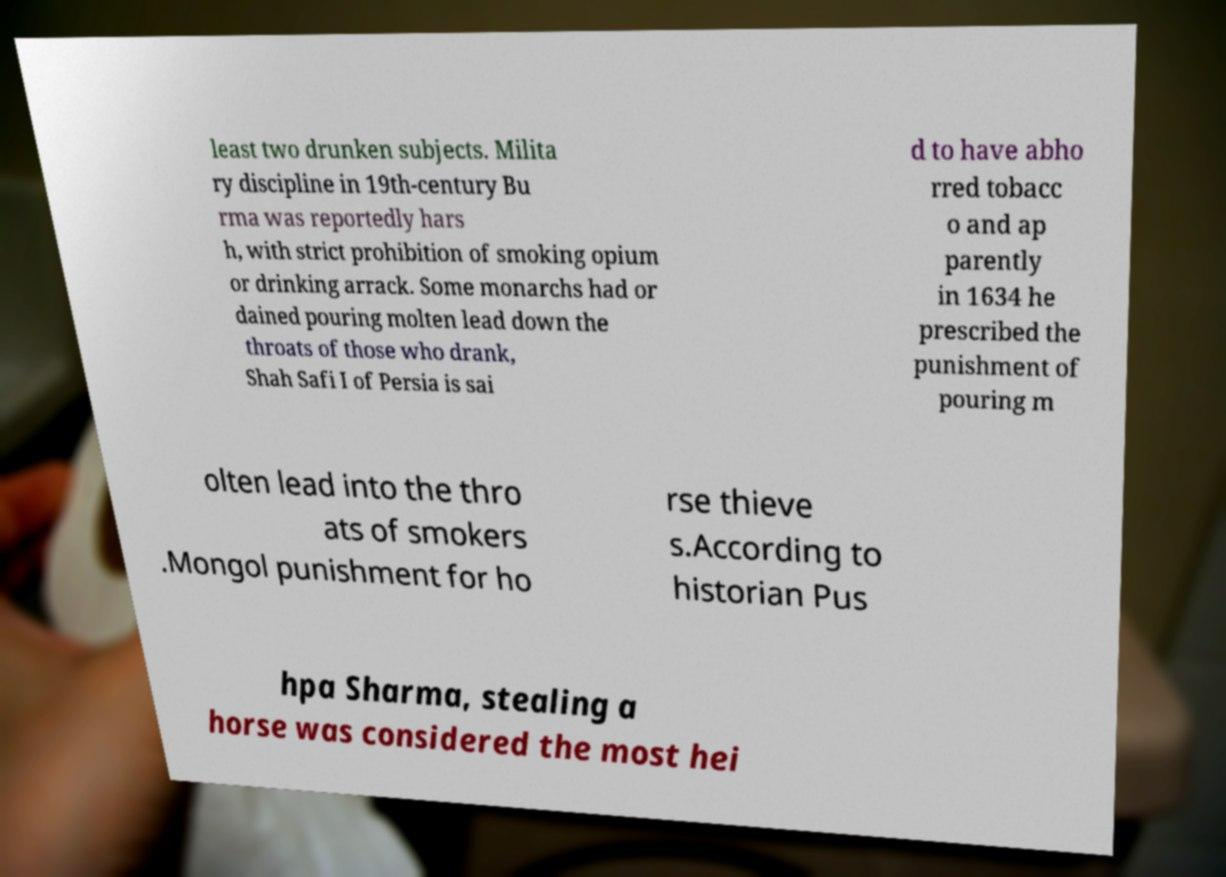Could you extract and type out the text from this image? least two drunken subjects. Milita ry discipline in 19th-century Bu rma was reportedly hars h, with strict prohibition of smoking opium or drinking arrack. Some monarchs had or dained pouring molten lead down the throats of those who drank, Shah Safi I of Persia is sai d to have abho rred tobacc o and ap parently in 1634 he prescribed the punishment of pouring m olten lead into the thro ats of smokers .Mongol punishment for ho rse thieve s.According to historian Pus hpa Sharma, stealing a horse was considered the most hei 